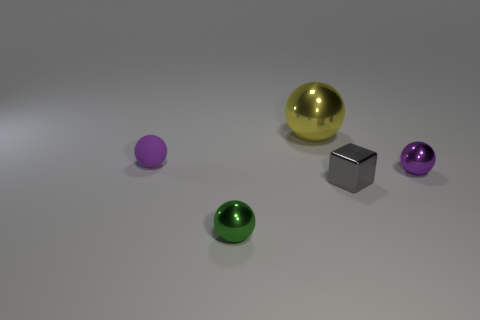How many other balls have the same size as the green metallic ball?
Your answer should be very brief. 2. What material is the small thing that is the same color as the small rubber ball?
Ensure brevity in your answer.  Metal. There is a tiny green thing that is on the right side of the matte thing; does it have the same shape as the rubber object?
Ensure brevity in your answer.  Yes. Is the number of shiny balls that are in front of the yellow object less than the number of small balls?
Offer a very short reply. Yes. Are there any other big shiny spheres that have the same color as the big shiny ball?
Provide a succinct answer. No. Is the shape of the gray shiny object the same as the purple object left of the green ball?
Offer a very short reply. No. Is there another tiny gray block that has the same material as the tiny cube?
Provide a short and direct response. No. There is a green sphere that is in front of the purple sphere on the right side of the small green shiny object; are there any gray metallic blocks that are in front of it?
Your answer should be very brief. No. How many other objects are there of the same shape as the small green metallic object?
Offer a terse response. 3. What color is the tiny shiny sphere on the right side of the tiny sphere that is in front of the tiny purple ball to the right of the small gray thing?
Your answer should be very brief. Purple. 